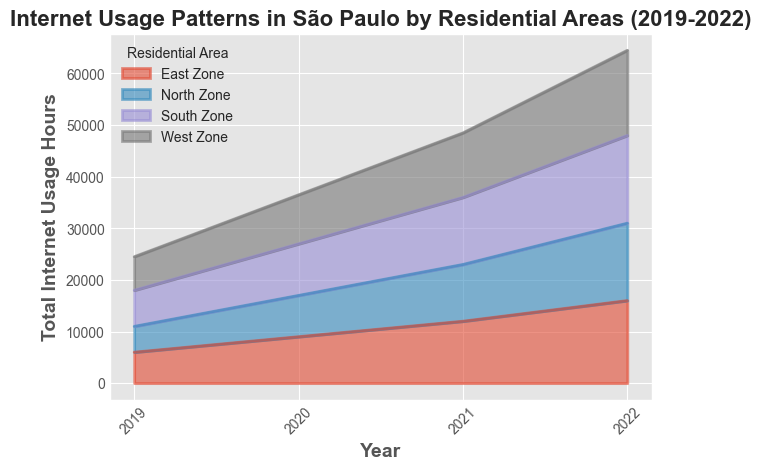How did the internet usage pattern in the North Zone change from 2019 to 2022? To find out how the internet usage pattern in the North Zone changed from 2019 to 2022, look at the values corresponding to these years for the North Zone. In 2019, the usage was 5000 hours, while in 2022 it increased to 15000 hours. Thus, there was an increase of 10000 hours over the period.
Answer: Increased by 10000 hours Which residential area witnessed the highest increase in internet usage hours from 2019 to 2022? To determine which area saw the highest increase, calculate the difference between the 2022 and 2019 values for each area. The increases are: North Zone (15000-5000=10000), South Zone (17000-7000=10000), East Zone (16000-6000=10000), West Zone (16500-6500=10000). All areas witnessed an equal increase of 10000 hours.
Answer: All areas equally increased by 10000 hours In 2020, did the South Zone or the East Zone have higher internet usage? For the year 2020, compare the internet usage values of the South Zone and East Zone. The South Zone has 10000 hours, while the East Zone has 9000 hours.
Answer: South Zone Among the four residential areas, which one had the least internet usage in 2019? Review values for each residential area in 2019. The North Zone had 5000 hours, South Zone 7000, East Zone 6000, and West Zone 6500. The North Zone had the least usage with 5000 hours.
Answer: North Zone Calculate the total internet usage hours across all residential areas in 2021. Sum the 2021 values for all zones: North Zone (11000) + South Zone (13000) + East Zone (12000) + West Zone (12500). Thus, the total is 11000 + 13000 + 12000 + 12500 = 48500 hours.
Answer: 48500 hours Compare the internet usage increment for the East Zone and West Zone between 2020 and 2021. Which area showed a larger increment, and by how much? Calculate the increments for both zones: East Zone increased from 9000 to 12000 (3000 hours), West Zone from 9500 to 12500 (3000 hours). Both areas had the same increment, so the difference is 0 hours.
Answer: Same increment, difference is 0 hours What is the percentage increase in internet usage hours in the South Zone from 2020 to 2022? Compute the increase (17000-10000 = 7000 hours) and use the initial value (10000) to find the percentage: (7000/10000)*100 = 70%.
Answer: 70% If the trend continues, what would be the expected internet usage in the North Zone in 2023? Observing the incremental pattern from 2019 to 2022, usage increased by 3000, 3000, and 4000 hours. Extrapolating with an average increase of 3333 (rounded), the estimate for 2023 is 15000 + 3333 ≈ 18333 hours.
Answer: Approx. 18333 hours 